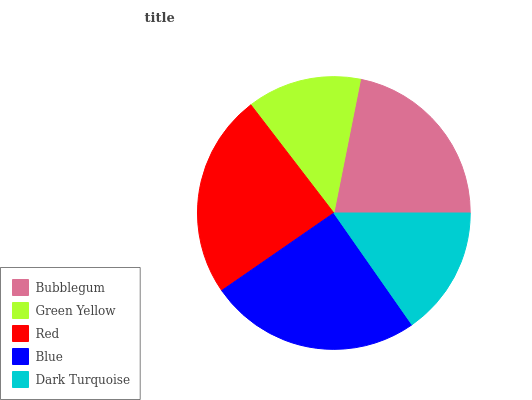Is Green Yellow the minimum?
Answer yes or no. Yes. Is Blue the maximum?
Answer yes or no. Yes. Is Red the minimum?
Answer yes or no. No. Is Red the maximum?
Answer yes or no. No. Is Red greater than Green Yellow?
Answer yes or no. Yes. Is Green Yellow less than Red?
Answer yes or no. Yes. Is Green Yellow greater than Red?
Answer yes or no. No. Is Red less than Green Yellow?
Answer yes or no. No. Is Bubblegum the high median?
Answer yes or no. Yes. Is Bubblegum the low median?
Answer yes or no. Yes. Is Blue the high median?
Answer yes or no. No. Is Red the low median?
Answer yes or no. No. 